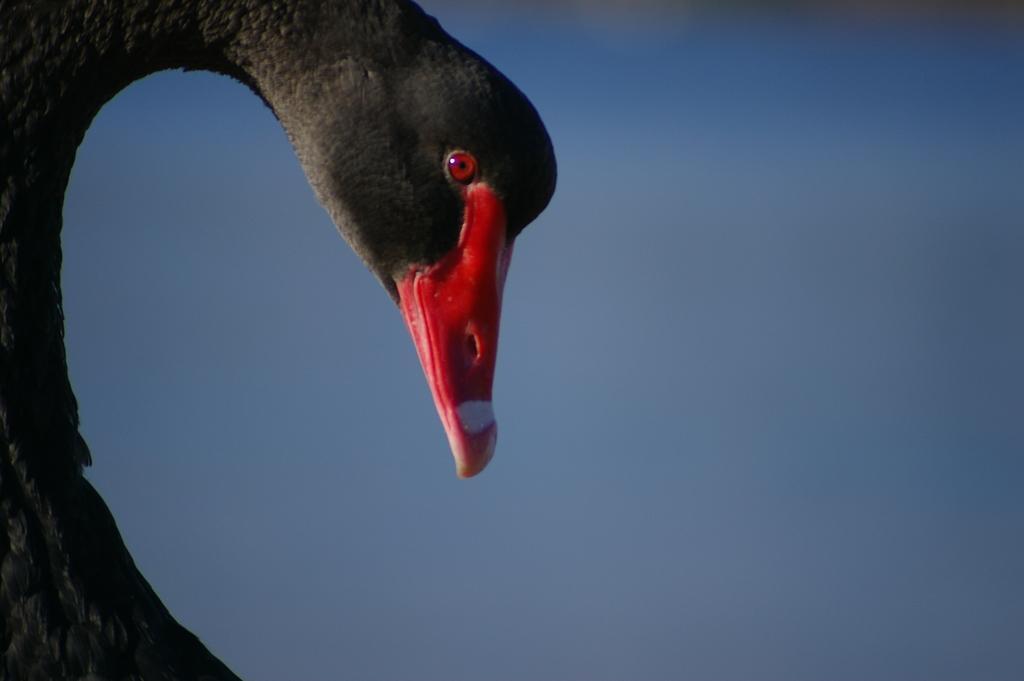Could you give a brief overview of what you see in this image? In this image, we can see the head of an animal, we can see the blue sky. 